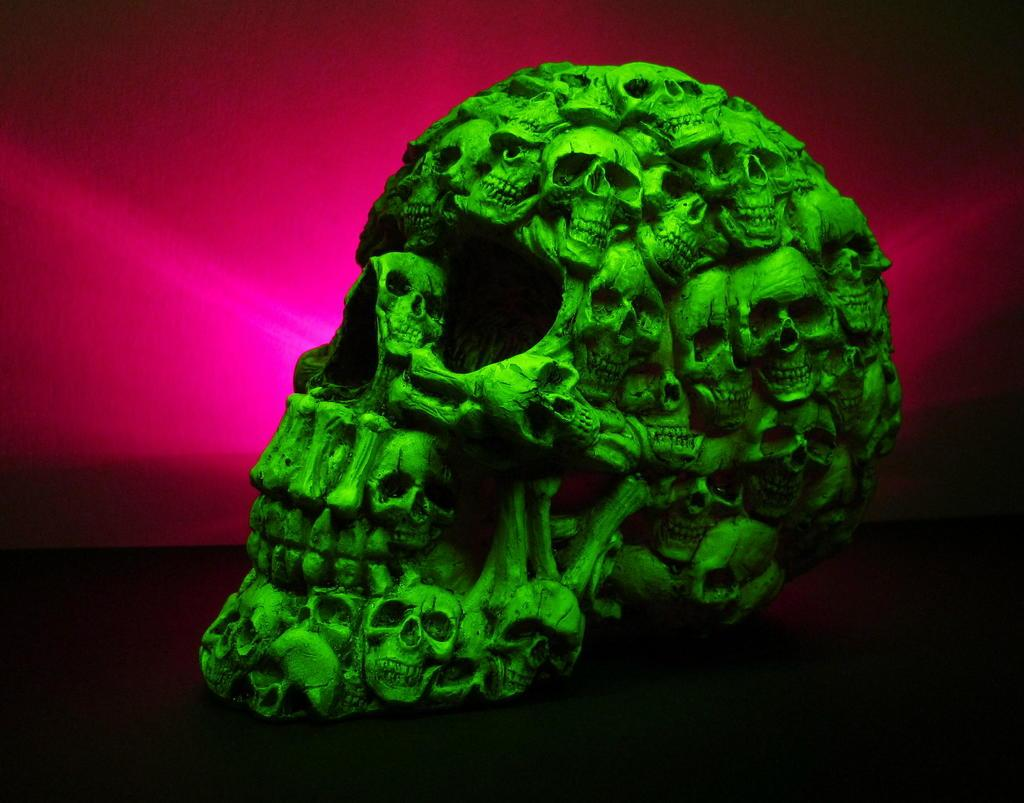What is the main subject of the image? The main subject of the image is a green color skull. Can you describe the appearance of the green skull? The green skull has multiple skull structures on it. What type of spark can be seen coming from the wrench in the image? There is no wrench present in the image, and therefore no spark can be observed. 